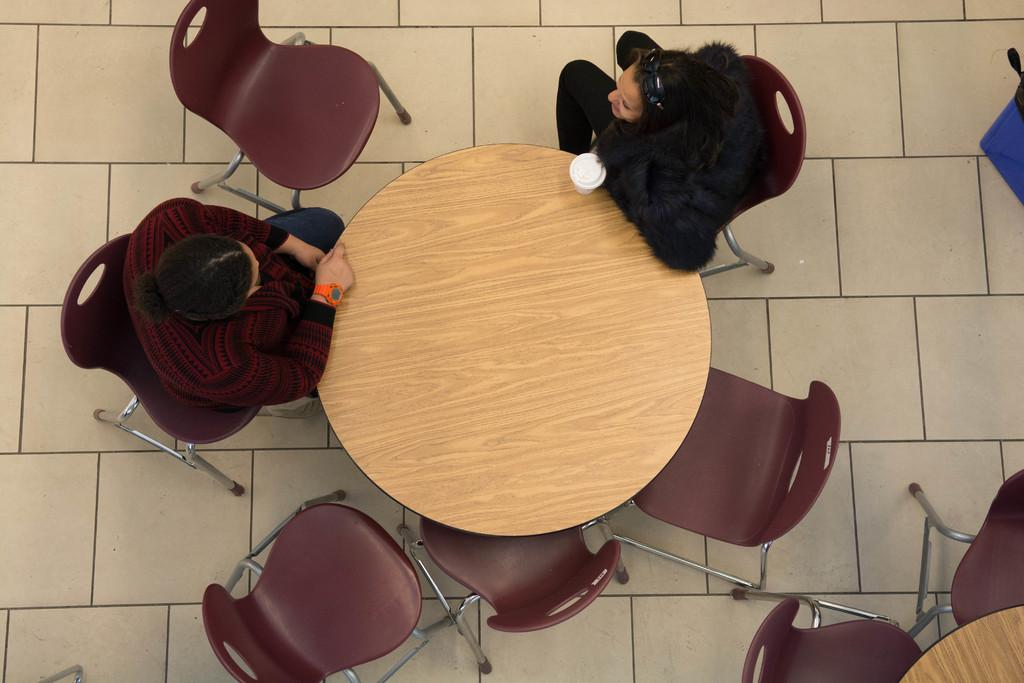What type of furniture is present in the image? There are chairs in the image. How many people are sitting on the chairs? Two people are sitting on the chairs. What is located in front of the chairs? There is a table in front of the chairs. What can be seen on the table? There is a glass on the table. What type of committee is meeting in the image? There is no committee meeting in the image; it only shows two people sitting on chairs with a table and a glass. Is there a net visible in the image? No, there is no net present in the image. 